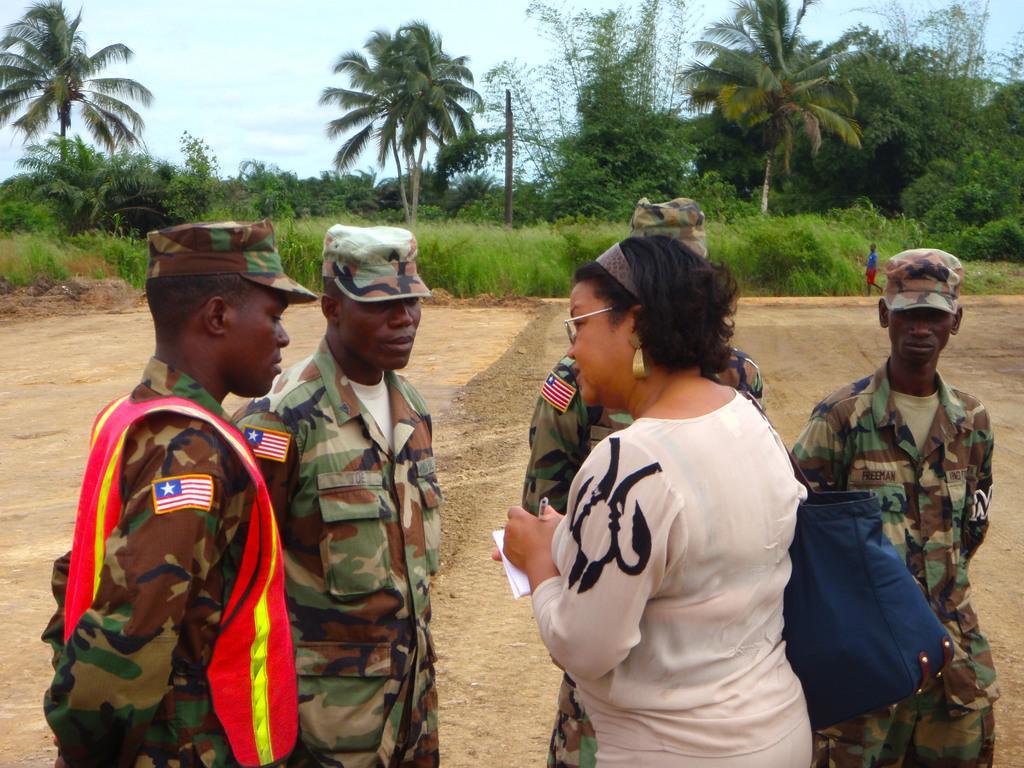Could you give a brief overview of what you see in this image? In-front of the image there are people. Among them one person wore a bag, holding book and pen. In the background there are trees, plants, person, pole and sky. 